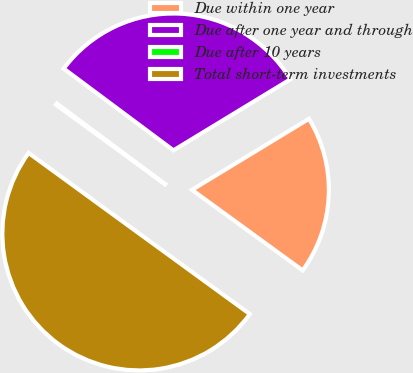Convert chart to OTSL. <chart><loc_0><loc_0><loc_500><loc_500><pie_chart><fcel>Due within one year<fcel>Due after one year and through<fcel>Due after 10 years<fcel>Total short-term investments<nl><fcel>18.7%<fcel>31.12%<fcel>0.17%<fcel>50.0%<nl></chart> 